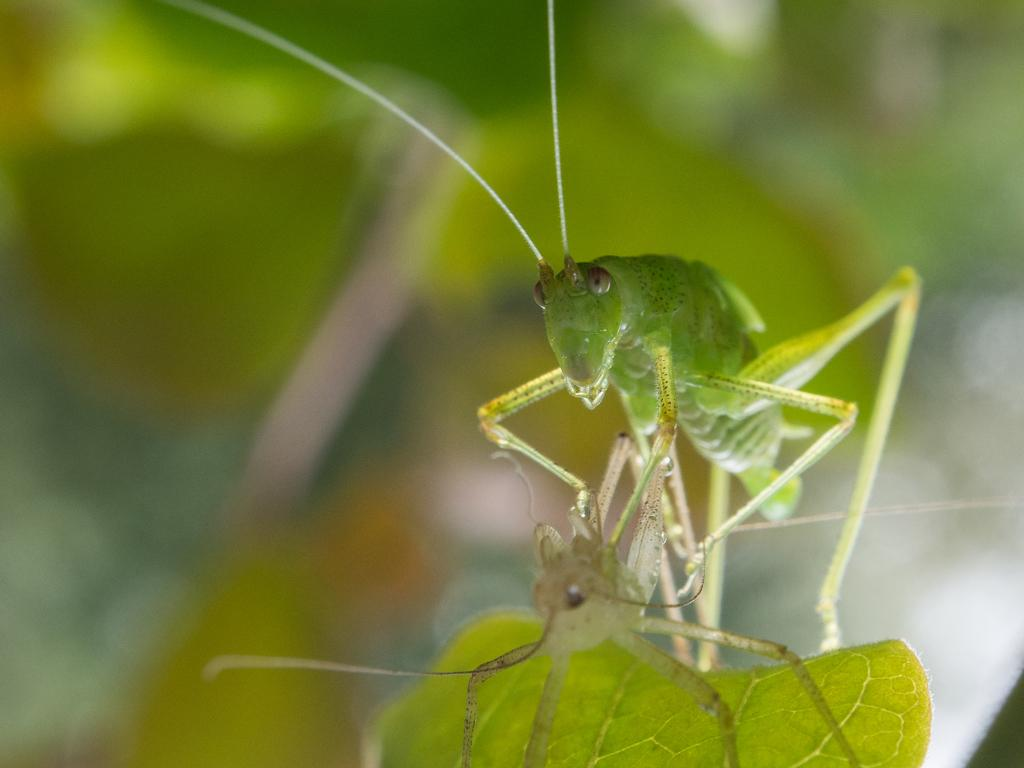What is the main subject of the image? The main subject of the image is insects on a leaf. Can you describe the background of the image? The background of the image is blurred. What type of support do the insects provide for their partner in the image? There is no indication in the image that the insects have a partner or provide support for one. 